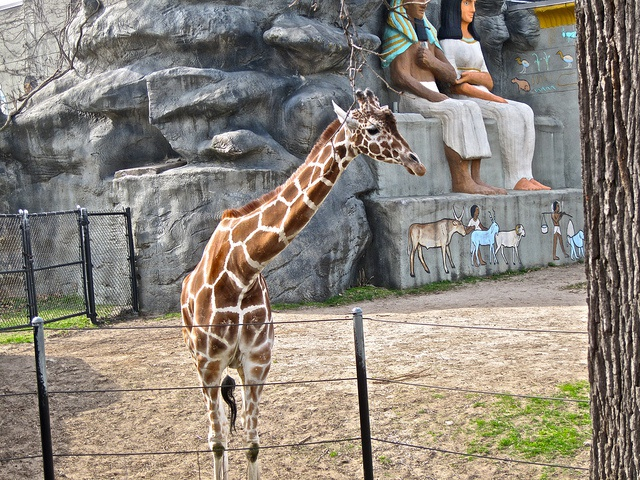Describe the objects in this image and their specific colors. I can see giraffe in white, gray, maroon, and darkgray tones, people in white, lightgray, darkgray, and gray tones, and people in white, lightgray, darkgray, black, and gray tones in this image. 